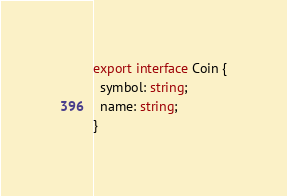Convert code to text. <code><loc_0><loc_0><loc_500><loc_500><_TypeScript_>export interface Coin {
  symbol: string;
  name: string;
}
</code> 